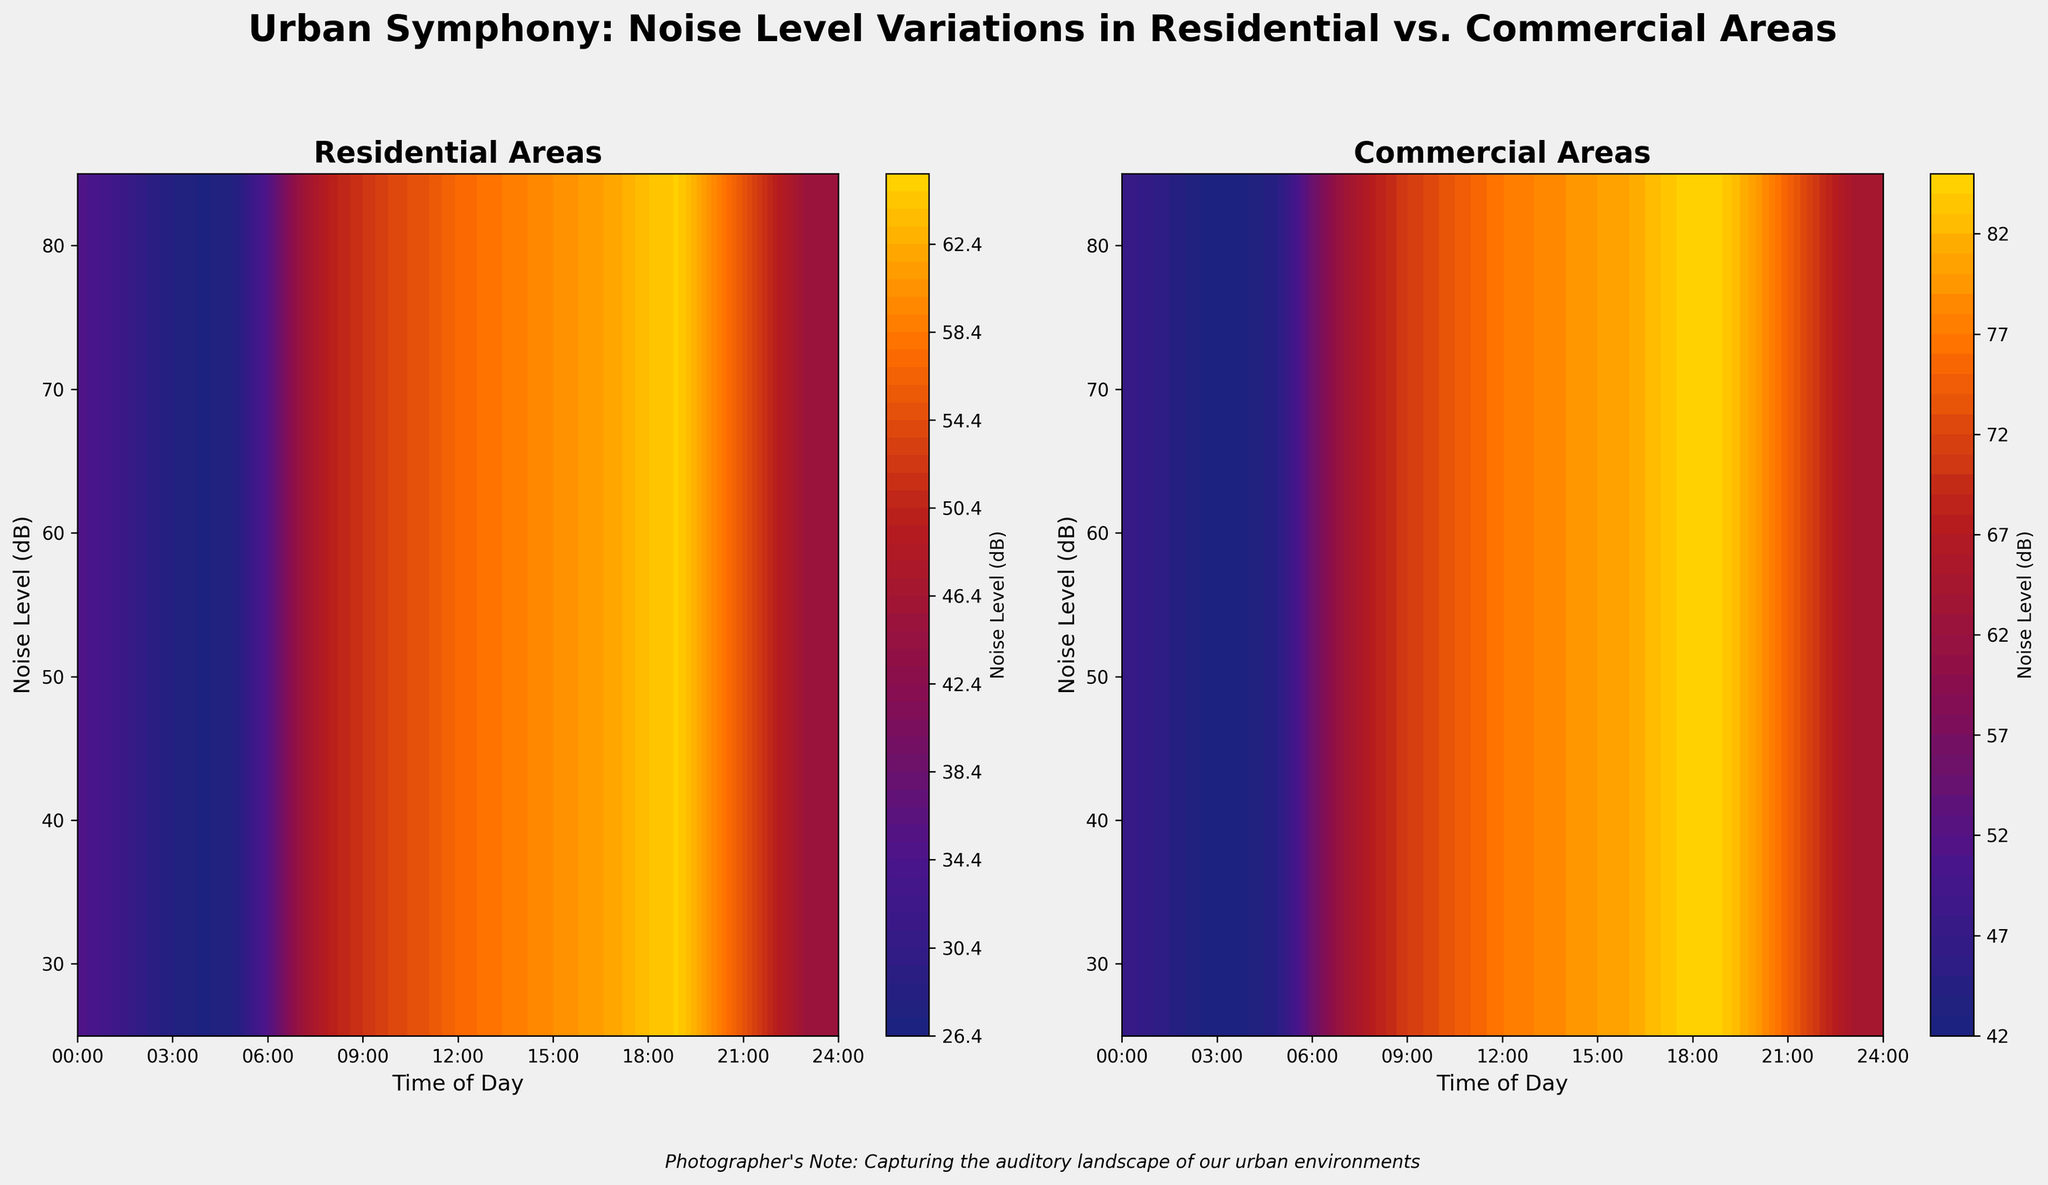What's the title of the figure? The title is located at the top of the figure and reads "Urban Symphony: Noise Level Variations in Residential vs. Commercial Areas".
Answer: Urban Symphony: Noise Level Variations in Residential vs. Commercial Areas What time of day is the highest noise level in residential areas? The highest noise level in residential areas can be found by looking at the peak in the contour plot on the left. The highest point is at 19:00 with a noise level of 65 dB.
Answer: 19:00 At which times do noise levels in residential areas rise sharply? By examining the contour plot on the left, noise levels in residential areas rise sharply between 06:00 and 08:00 and again from 17:00 to 19:00.
Answer: 06:00 to 08:00, and 17:00 to 19:00 Between which hours do commercial areas exhibit a continuous increase in noise level? By analyzing the contour plot on the right, commercial areas show a continuous increase in noise level from 05:00 to 18:00 where the noise level increases from 45 dB to 85 dB.
Answer: 05:00 to 18:00 Compare the noise levels at 12:00 in residential and commercial areas. To compare, find 12:00 on both contour plots. Residential noise level is 57 dB, and commercial is 77 dB. Hence, commercial areas are noisier.
Answer: Commercial areas are noisier Which area shows a more drastic change in noise level throughout the day? By comparing both contour plots, commercial areas show a wider range (44 dB at 03:00 to 85 dB at 18:00) than residential areas (28 dB at 03:00 to 65 dB at 19:00), indicating a more drastic change.
Answer: Commercial areas How does the noise level at 03:00 compare to 15:00 in residential areas? At 03:00, the noise level is 28 dB in residential areas. At 15:00, it is 60 dB. By subtracting, we see a significant increase of 32 dB.
Answer: Significant increase of 32 dB What is the range of noise levels in commercial areas? The range can be calculated by subtracting the lowest noise level (42 dB at 03:00) from the highest (85 dB at 18:00).
Answer: 43 dB Are there any times when the noise levels in residential and commercial areas are nearly equal? By comparing both plots, the times that have nearly equal noise levels are at 05:00 (28 dB in residential and 45 dB in commercial) which is not close, indicating no equal points represented.
Answer: No, they are not equal Which period has a decrease in noise level in both residential and commercial areas? Both residential and commercial areas show a noise level decrease from 19:00 to 22:00. In residential areas, it drops from 65 dB to 55 dB, and in commercial areas from 84 dB to 75 dB.
Answer: 19:00 to 22:00 